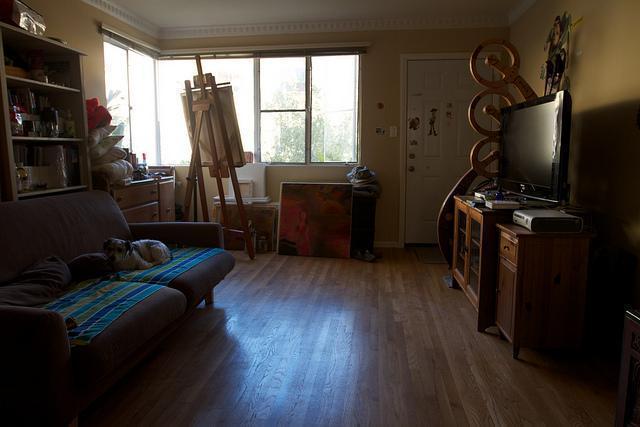What is likely on the item by the window?
Select the correct answer and articulate reasoning with the following format: 'Answer: answer
Rationale: rationale.'
Options: Clothes, television, food, painting. Answer: painting.
Rationale: When people paint, they use an easel to hold up their canvas. 